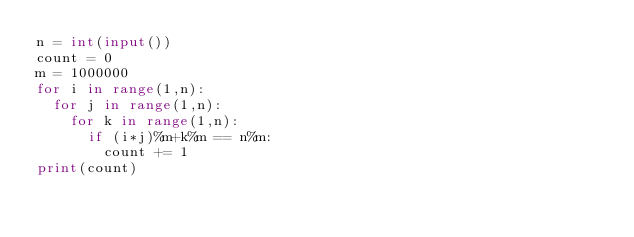<code> <loc_0><loc_0><loc_500><loc_500><_Python_>n = int(input())
count = 0
m = 1000000
for i in range(1,n):
  for j in range(1,n):
    for k in range(1,n):
      if (i*j)%m+k%m == n%m:
        count += 1
print(count)            </code> 